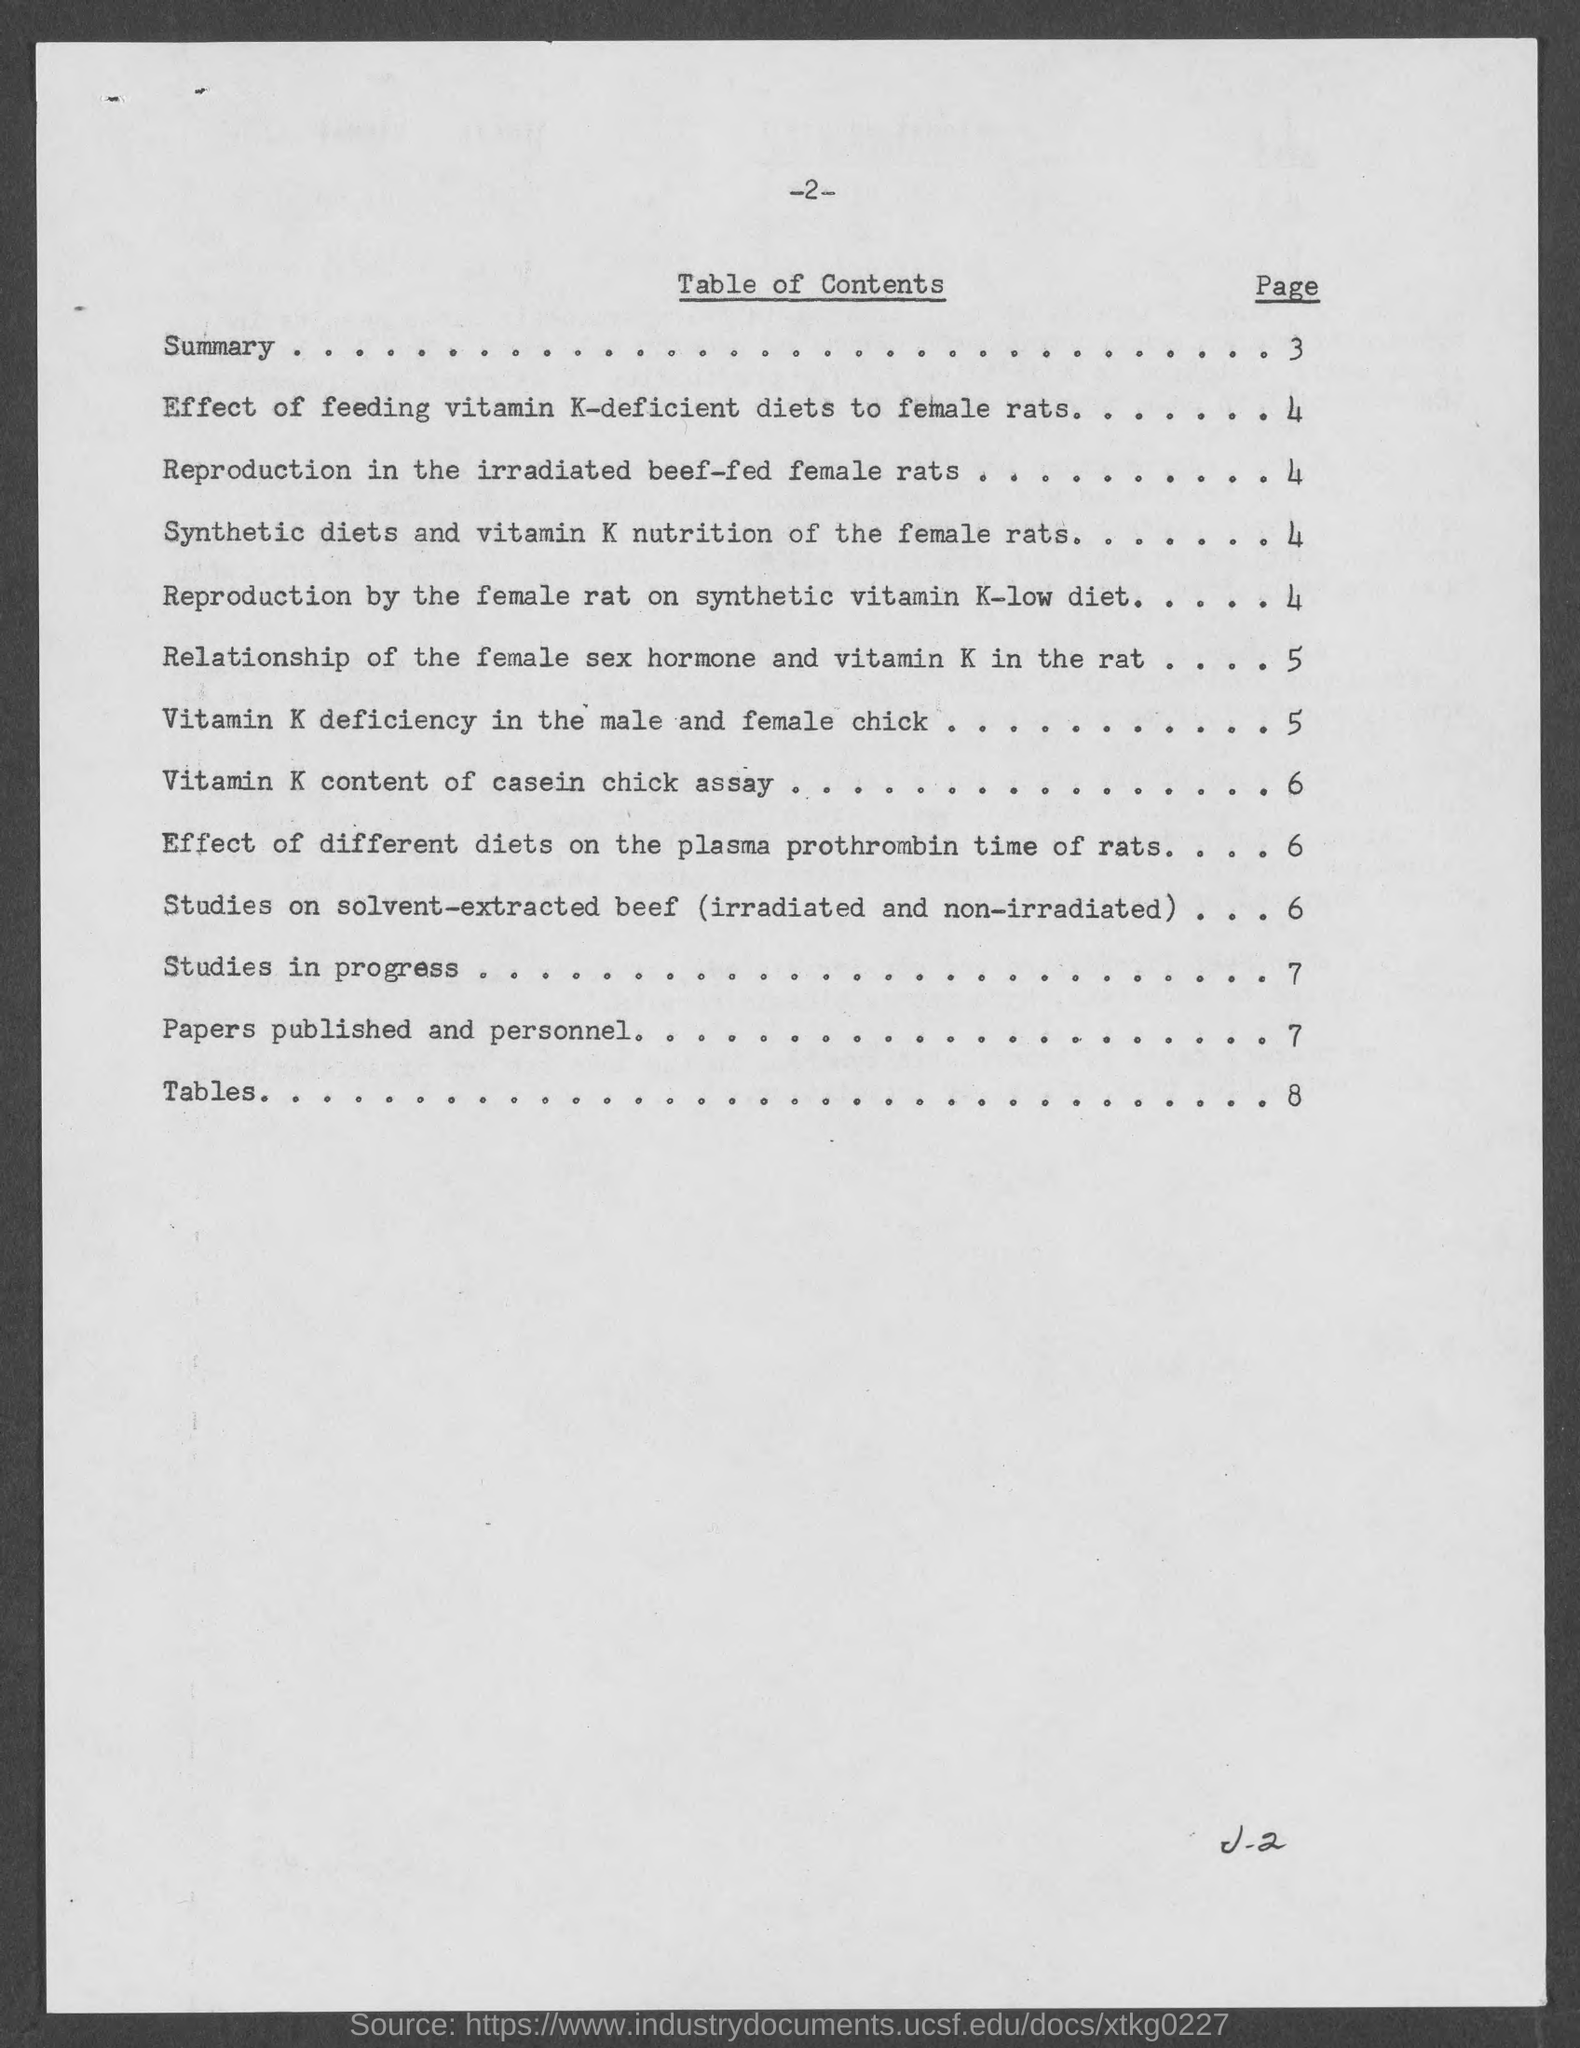In which page number is "Summary"?
Your answer should be very brief. 3. In which page number is  "Tables"?
Provide a short and direct response. 8. In which page number is  "Studies in Progress"?
Provide a succinct answer. 7. 